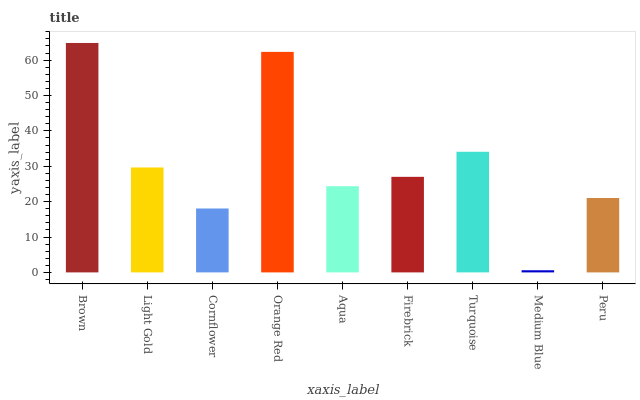Is Light Gold the minimum?
Answer yes or no. No. Is Light Gold the maximum?
Answer yes or no. No. Is Brown greater than Light Gold?
Answer yes or no. Yes. Is Light Gold less than Brown?
Answer yes or no. Yes. Is Light Gold greater than Brown?
Answer yes or no. No. Is Brown less than Light Gold?
Answer yes or no. No. Is Firebrick the high median?
Answer yes or no. Yes. Is Firebrick the low median?
Answer yes or no. Yes. Is Medium Blue the high median?
Answer yes or no. No. Is Light Gold the low median?
Answer yes or no. No. 